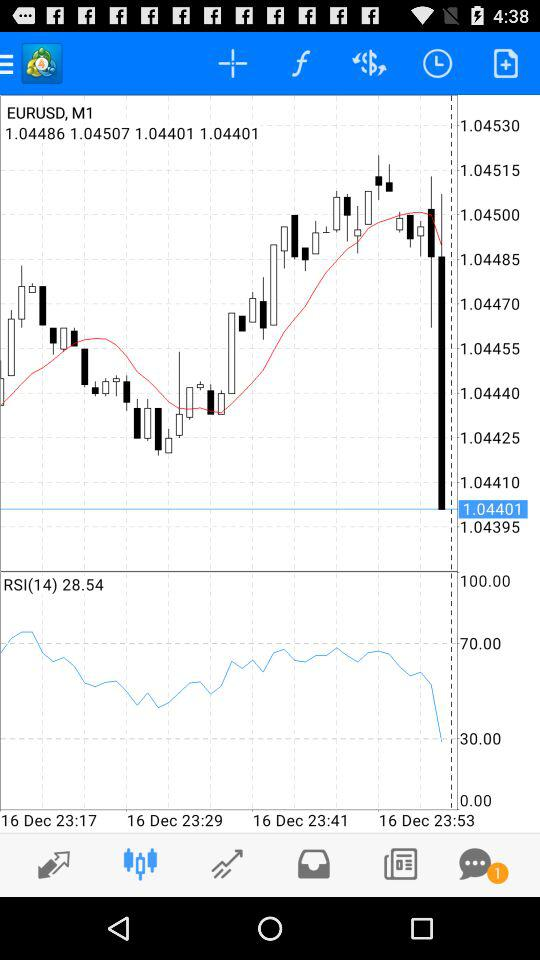Is there any unread chat? There is one unread chat. 